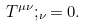Convert formula to latex. <formula><loc_0><loc_0><loc_500><loc_500>T ^ { \mu \nu } ; _ { \nu } = 0 .</formula> 